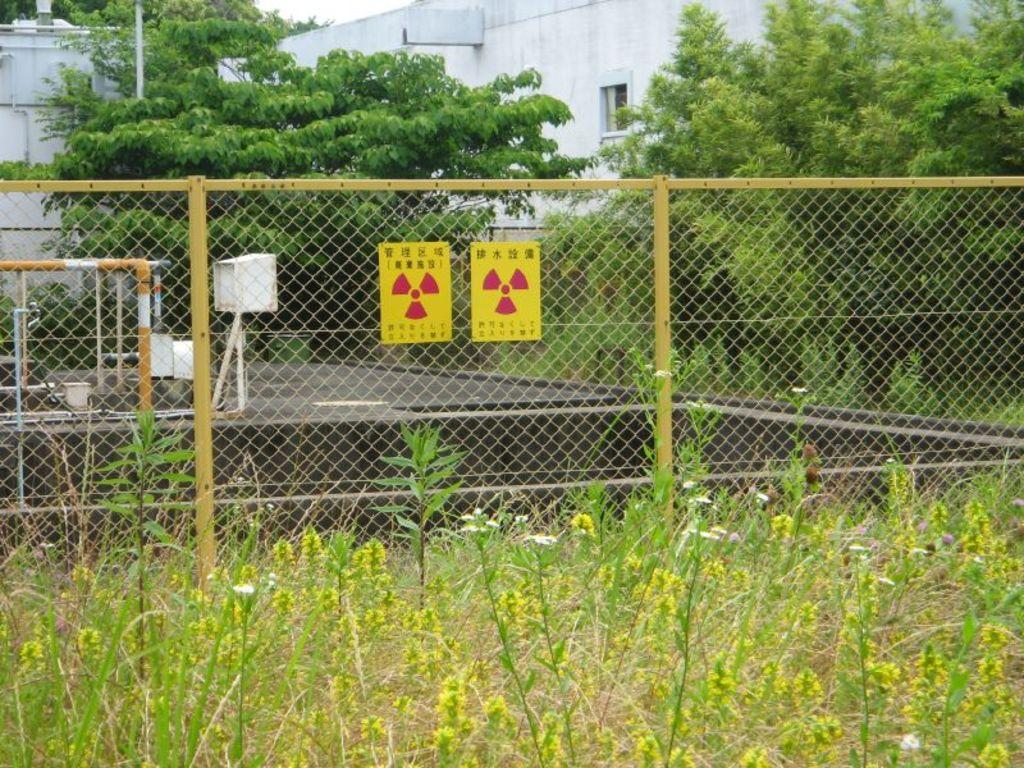What type of living organisms can be seen in the image? Plants and trees are visible in the image. What is located in the front of the image? There is a fencing in the front of the image. What can be seen in the background of the image? Trees and buildings with white color can be seen in the background of the image. What type of soda can be seen in the image? There is no soda present in the image. What type of beast can be seen interacting with the plants in the image? There is no beast present in the image; only plants, trees, and fencing are visible. 